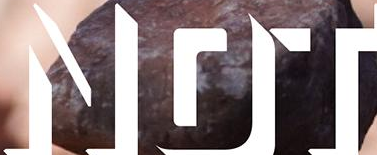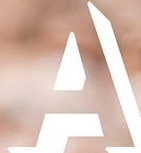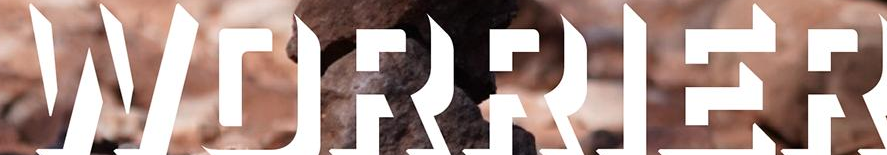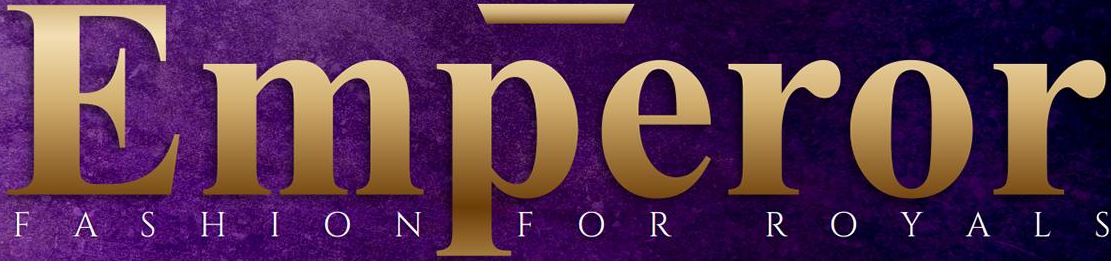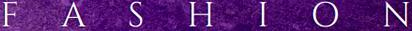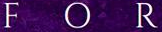What words can you see in these images in sequence, separated by a semicolon? NOT; A; WORRIER; Emperor; FASHION; FOR 